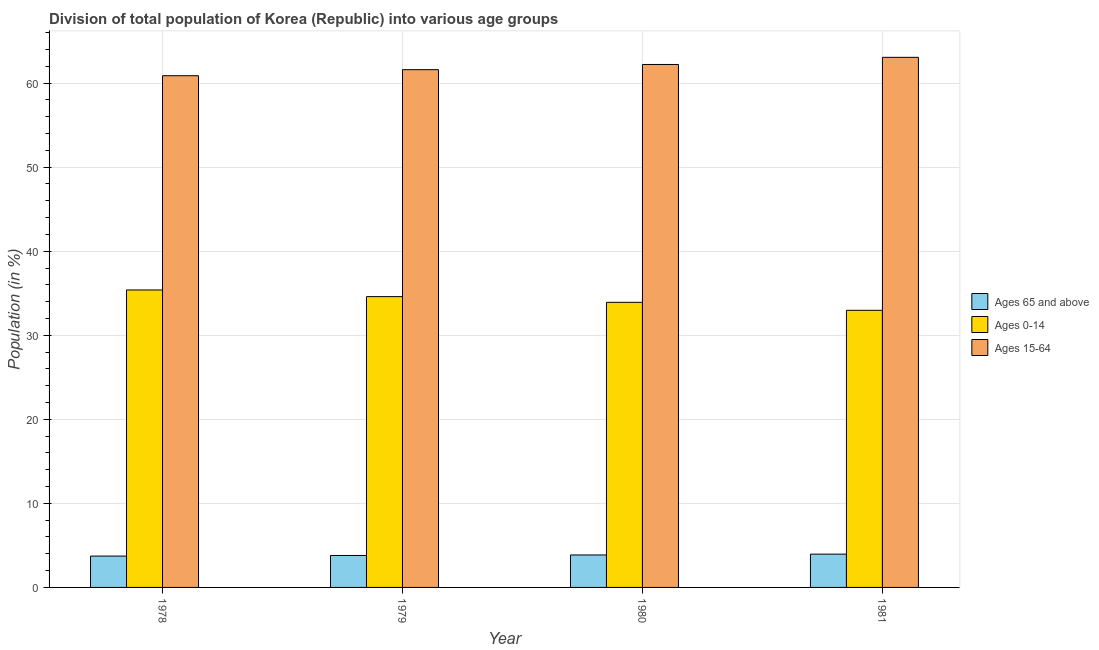How many different coloured bars are there?
Your answer should be very brief. 3. How many groups of bars are there?
Offer a very short reply. 4. Are the number of bars per tick equal to the number of legend labels?
Give a very brief answer. Yes. Are the number of bars on each tick of the X-axis equal?
Provide a short and direct response. Yes. How many bars are there on the 2nd tick from the right?
Your response must be concise. 3. What is the label of the 1st group of bars from the left?
Your answer should be very brief. 1978. In how many cases, is the number of bars for a given year not equal to the number of legend labels?
Your answer should be very brief. 0. What is the percentage of population within the age-group 0-14 in 1979?
Provide a short and direct response. 34.6. Across all years, what is the maximum percentage of population within the age-group of 65 and above?
Your answer should be compact. 3.96. Across all years, what is the minimum percentage of population within the age-group 0-14?
Give a very brief answer. 32.97. In which year was the percentage of population within the age-group of 65 and above minimum?
Keep it short and to the point. 1978. What is the total percentage of population within the age-group of 65 and above in the graph?
Keep it short and to the point. 15.35. What is the difference between the percentage of population within the age-group of 65 and above in 1979 and that in 1980?
Your answer should be compact. -0.06. What is the difference between the percentage of population within the age-group 15-64 in 1981 and the percentage of population within the age-group of 65 and above in 1979?
Keep it short and to the point. 1.47. What is the average percentage of population within the age-group 15-64 per year?
Provide a succinct answer. 61.94. In how many years, is the percentage of population within the age-group of 65 and above greater than 12 %?
Your response must be concise. 0. What is the ratio of the percentage of population within the age-group 0-14 in 1980 to that in 1981?
Your answer should be very brief. 1.03. Is the percentage of population within the age-group 15-64 in 1979 less than that in 1981?
Your answer should be very brief. Yes. What is the difference between the highest and the second highest percentage of population within the age-group of 65 and above?
Offer a terse response. 0.1. What is the difference between the highest and the lowest percentage of population within the age-group 15-64?
Make the answer very short. 2.19. What does the 2nd bar from the left in 1978 represents?
Ensure brevity in your answer.  Ages 0-14. What does the 2nd bar from the right in 1980 represents?
Your answer should be compact. Ages 0-14. How many years are there in the graph?
Provide a short and direct response. 4. Where does the legend appear in the graph?
Keep it short and to the point. Center right. What is the title of the graph?
Offer a terse response. Division of total population of Korea (Republic) into various age groups
. What is the Population (in %) in Ages 65 and above in 1978?
Your answer should be compact. 3.73. What is the Population (in %) in Ages 0-14 in 1978?
Provide a short and direct response. 35.39. What is the Population (in %) of Ages 15-64 in 1978?
Your answer should be very brief. 60.88. What is the Population (in %) of Ages 65 and above in 1979?
Ensure brevity in your answer.  3.8. What is the Population (in %) in Ages 0-14 in 1979?
Your response must be concise. 34.6. What is the Population (in %) in Ages 15-64 in 1979?
Your answer should be very brief. 61.6. What is the Population (in %) of Ages 65 and above in 1980?
Ensure brevity in your answer.  3.86. What is the Population (in %) of Ages 0-14 in 1980?
Provide a succinct answer. 33.92. What is the Population (in %) in Ages 15-64 in 1980?
Give a very brief answer. 62.22. What is the Population (in %) in Ages 65 and above in 1981?
Keep it short and to the point. 3.96. What is the Population (in %) of Ages 0-14 in 1981?
Offer a terse response. 32.97. What is the Population (in %) in Ages 15-64 in 1981?
Keep it short and to the point. 63.07. Across all years, what is the maximum Population (in %) of Ages 65 and above?
Your answer should be compact. 3.96. Across all years, what is the maximum Population (in %) of Ages 0-14?
Your answer should be very brief. 35.39. Across all years, what is the maximum Population (in %) in Ages 15-64?
Give a very brief answer. 63.07. Across all years, what is the minimum Population (in %) of Ages 65 and above?
Provide a short and direct response. 3.73. Across all years, what is the minimum Population (in %) in Ages 0-14?
Provide a succinct answer. 32.97. Across all years, what is the minimum Population (in %) of Ages 15-64?
Offer a very short reply. 60.88. What is the total Population (in %) of Ages 65 and above in the graph?
Provide a succinct answer. 15.35. What is the total Population (in %) in Ages 0-14 in the graph?
Make the answer very short. 136.88. What is the total Population (in %) in Ages 15-64 in the graph?
Ensure brevity in your answer.  247.77. What is the difference between the Population (in %) of Ages 65 and above in 1978 and that in 1979?
Offer a very short reply. -0.07. What is the difference between the Population (in %) of Ages 0-14 in 1978 and that in 1979?
Provide a short and direct response. 0.79. What is the difference between the Population (in %) of Ages 15-64 in 1978 and that in 1979?
Offer a terse response. -0.72. What is the difference between the Population (in %) of Ages 65 and above in 1978 and that in 1980?
Offer a terse response. -0.13. What is the difference between the Population (in %) in Ages 0-14 in 1978 and that in 1980?
Provide a succinct answer. 1.47. What is the difference between the Population (in %) in Ages 15-64 in 1978 and that in 1980?
Offer a terse response. -1.34. What is the difference between the Population (in %) in Ages 65 and above in 1978 and that in 1981?
Offer a very short reply. -0.23. What is the difference between the Population (in %) in Ages 0-14 in 1978 and that in 1981?
Your answer should be compact. 2.42. What is the difference between the Population (in %) of Ages 15-64 in 1978 and that in 1981?
Give a very brief answer. -2.19. What is the difference between the Population (in %) of Ages 65 and above in 1979 and that in 1980?
Your response must be concise. -0.06. What is the difference between the Population (in %) in Ages 0-14 in 1979 and that in 1980?
Offer a very short reply. 0.68. What is the difference between the Population (in %) of Ages 15-64 in 1979 and that in 1980?
Keep it short and to the point. -0.62. What is the difference between the Population (in %) in Ages 65 and above in 1979 and that in 1981?
Make the answer very short. -0.16. What is the difference between the Population (in %) in Ages 0-14 in 1979 and that in 1981?
Offer a terse response. 1.63. What is the difference between the Population (in %) in Ages 15-64 in 1979 and that in 1981?
Your answer should be very brief. -1.47. What is the difference between the Population (in %) in Ages 65 and above in 1980 and that in 1981?
Give a very brief answer. -0.1. What is the difference between the Population (in %) of Ages 0-14 in 1980 and that in 1981?
Your answer should be compact. 0.95. What is the difference between the Population (in %) in Ages 15-64 in 1980 and that in 1981?
Keep it short and to the point. -0.85. What is the difference between the Population (in %) in Ages 65 and above in 1978 and the Population (in %) in Ages 0-14 in 1979?
Your response must be concise. -30.87. What is the difference between the Population (in %) of Ages 65 and above in 1978 and the Population (in %) of Ages 15-64 in 1979?
Provide a succinct answer. -57.87. What is the difference between the Population (in %) in Ages 0-14 in 1978 and the Population (in %) in Ages 15-64 in 1979?
Your answer should be compact. -26.21. What is the difference between the Population (in %) of Ages 65 and above in 1978 and the Population (in %) of Ages 0-14 in 1980?
Give a very brief answer. -30.19. What is the difference between the Population (in %) of Ages 65 and above in 1978 and the Population (in %) of Ages 15-64 in 1980?
Make the answer very short. -58.49. What is the difference between the Population (in %) of Ages 0-14 in 1978 and the Population (in %) of Ages 15-64 in 1980?
Provide a short and direct response. -26.83. What is the difference between the Population (in %) in Ages 65 and above in 1978 and the Population (in %) in Ages 0-14 in 1981?
Provide a short and direct response. -29.24. What is the difference between the Population (in %) of Ages 65 and above in 1978 and the Population (in %) of Ages 15-64 in 1981?
Offer a very short reply. -59.34. What is the difference between the Population (in %) of Ages 0-14 in 1978 and the Population (in %) of Ages 15-64 in 1981?
Offer a terse response. -27.68. What is the difference between the Population (in %) in Ages 65 and above in 1979 and the Population (in %) in Ages 0-14 in 1980?
Offer a very short reply. -30.12. What is the difference between the Population (in %) in Ages 65 and above in 1979 and the Population (in %) in Ages 15-64 in 1980?
Offer a very short reply. -58.42. What is the difference between the Population (in %) in Ages 0-14 in 1979 and the Population (in %) in Ages 15-64 in 1980?
Your answer should be compact. -27.62. What is the difference between the Population (in %) in Ages 65 and above in 1979 and the Population (in %) in Ages 0-14 in 1981?
Give a very brief answer. -29.17. What is the difference between the Population (in %) of Ages 65 and above in 1979 and the Population (in %) of Ages 15-64 in 1981?
Offer a very short reply. -59.27. What is the difference between the Population (in %) in Ages 0-14 in 1979 and the Population (in %) in Ages 15-64 in 1981?
Provide a succinct answer. -28.47. What is the difference between the Population (in %) of Ages 65 and above in 1980 and the Population (in %) of Ages 0-14 in 1981?
Offer a terse response. -29.11. What is the difference between the Population (in %) of Ages 65 and above in 1980 and the Population (in %) of Ages 15-64 in 1981?
Your response must be concise. -59.21. What is the difference between the Population (in %) of Ages 0-14 in 1980 and the Population (in %) of Ages 15-64 in 1981?
Provide a succinct answer. -29.15. What is the average Population (in %) in Ages 65 and above per year?
Provide a succinct answer. 3.84. What is the average Population (in %) in Ages 0-14 per year?
Your response must be concise. 34.22. What is the average Population (in %) of Ages 15-64 per year?
Ensure brevity in your answer.  61.94. In the year 1978, what is the difference between the Population (in %) in Ages 65 and above and Population (in %) in Ages 0-14?
Provide a succinct answer. -31.66. In the year 1978, what is the difference between the Population (in %) in Ages 65 and above and Population (in %) in Ages 15-64?
Your answer should be very brief. -57.15. In the year 1978, what is the difference between the Population (in %) in Ages 0-14 and Population (in %) in Ages 15-64?
Provide a short and direct response. -25.49. In the year 1979, what is the difference between the Population (in %) in Ages 65 and above and Population (in %) in Ages 0-14?
Provide a succinct answer. -30.8. In the year 1979, what is the difference between the Population (in %) in Ages 65 and above and Population (in %) in Ages 15-64?
Offer a very short reply. -57.8. In the year 1979, what is the difference between the Population (in %) in Ages 0-14 and Population (in %) in Ages 15-64?
Make the answer very short. -27. In the year 1980, what is the difference between the Population (in %) in Ages 65 and above and Population (in %) in Ages 0-14?
Provide a succinct answer. -30.06. In the year 1980, what is the difference between the Population (in %) in Ages 65 and above and Population (in %) in Ages 15-64?
Keep it short and to the point. -58.36. In the year 1980, what is the difference between the Population (in %) in Ages 0-14 and Population (in %) in Ages 15-64?
Offer a very short reply. -28.3. In the year 1981, what is the difference between the Population (in %) of Ages 65 and above and Population (in %) of Ages 0-14?
Make the answer very short. -29.01. In the year 1981, what is the difference between the Population (in %) of Ages 65 and above and Population (in %) of Ages 15-64?
Ensure brevity in your answer.  -59.11. In the year 1981, what is the difference between the Population (in %) of Ages 0-14 and Population (in %) of Ages 15-64?
Your response must be concise. -30.1. What is the ratio of the Population (in %) in Ages 0-14 in 1978 to that in 1979?
Provide a succinct answer. 1.02. What is the ratio of the Population (in %) of Ages 15-64 in 1978 to that in 1979?
Keep it short and to the point. 0.99. What is the ratio of the Population (in %) in Ages 65 and above in 1978 to that in 1980?
Offer a terse response. 0.97. What is the ratio of the Population (in %) in Ages 0-14 in 1978 to that in 1980?
Make the answer very short. 1.04. What is the ratio of the Population (in %) in Ages 15-64 in 1978 to that in 1980?
Make the answer very short. 0.98. What is the ratio of the Population (in %) of Ages 65 and above in 1978 to that in 1981?
Make the answer very short. 0.94. What is the ratio of the Population (in %) of Ages 0-14 in 1978 to that in 1981?
Your answer should be compact. 1.07. What is the ratio of the Population (in %) of Ages 15-64 in 1978 to that in 1981?
Ensure brevity in your answer.  0.97. What is the ratio of the Population (in %) in Ages 65 and above in 1979 to that in 1980?
Make the answer very short. 0.98. What is the ratio of the Population (in %) of Ages 15-64 in 1979 to that in 1980?
Give a very brief answer. 0.99. What is the ratio of the Population (in %) of Ages 65 and above in 1979 to that in 1981?
Your answer should be compact. 0.96. What is the ratio of the Population (in %) of Ages 0-14 in 1979 to that in 1981?
Provide a short and direct response. 1.05. What is the ratio of the Population (in %) of Ages 15-64 in 1979 to that in 1981?
Ensure brevity in your answer.  0.98. What is the ratio of the Population (in %) in Ages 65 and above in 1980 to that in 1981?
Provide a short and direct response. 0.97. What is the ratio of the Population (in %) of Ages 0-14 in 1980 to that in 1981?
Offer a very short reply. 1.03. What is the ratio of the Population (in %) in Ages 15-64 in 1980 to that in 1981?
Make the answer very short. 0.99. What is the difference between the highest and the second highest Population (in %) in Ages 65 and above?
Your answer should be very brief. 0.1. What is the difference between the highest and the second highest Population (in %) of Ages 0-14?
Provide a short and direct response. 0.79. What is the difference between the highest and the second highest Population (in %) of Ages 15-64?
Offer a very short reply. 0.85. What is the difference between the highest and the lowest Population (in %) in Ages 65 and above?
Make the answer very short. 0.23. What is the difference between the highest and the lowest Population (in %) of Ages 0-14?
Make the answer very short. 2.42. What is the difference between the highest and the lowest Population (in %) of Ages 15-64?
Give a very brief answer. 2.19. 